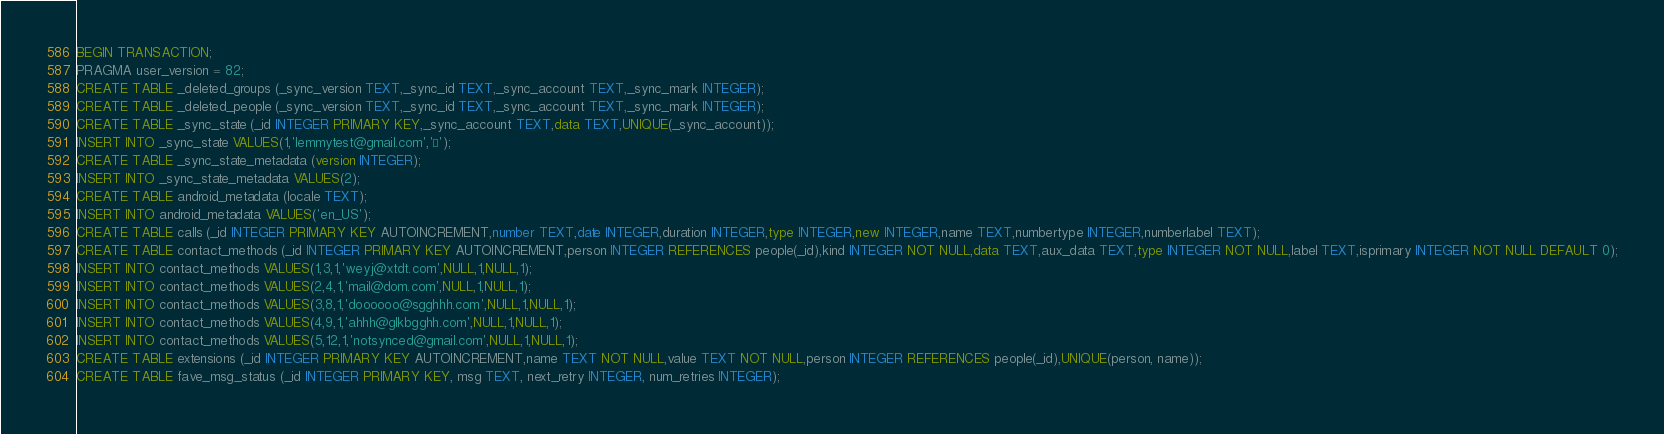Convert code to text. <code><loc_0><loc_0><loc_500><loc_500><_SQL_>BEGIN TRANSACTION;
PRAGMA user_version = 82; 
CREATE TABLE _deleted_groups (_sync_version TEXT,_sync_id TEXT,_sync_account TEXT,_sync_mark INTEGER);
CREATE TABLE _deleted_people (_sync_version TEXT,_sync_id TEXT,_sync_account TEXT,_sync_mark INTEGER);
CREATE TABLE _sync_state (_id INTEGER PRIMARY KEY,_sync_account TEXT,data TEXT,UNIQUE(_sync_account));
INSERT INTO _sync_state VALUES(1,'lemmytest@gmail.com','');
CREATE TABLE _sync_state_metadata (version INTEGER);
INSERT INTO _sync_state_metadata VALUES(2);
CREATE TABLE android_metadata (locale TEXT);
INSERT INTO android_metadata VALUES('en_US');
CREATE TABLE calls (_id INTEGER PRIMARY KEY AUTOINCREMENT,number TEXT,date INTEGER,duration INTEGER,type INTEGER,new INTEGER,name TEXT,numbertype INTEGER,numberlabel TEXT);
CREATE TABLE contact_methods (_id INTEGER PRIMARY KEY AUTOINCREMENT,person INTEGER REFERENCES people(_id),kind INTEGER NOT NULL,data TEXT,aux_data TEXT,type INTEGER NOT NULL,label TEXT,isprimary INTEGER NOT NULL DEFAULT 0);
INSERT INTO contact_methods VALUES(1,3,1,'weyj@xtdt.com',NULL,1,NULL,1);
INSERT INTO contact_methods VALUES(2,4,1,'mail@dom.com',NULL,1,NULL,1);
INSERT INTO contact_methods VALUES(3,8,1,'doooooo@sgghhh.com',NULL,1,NULL,1);
INSERT INTO contact_methods VALUES(4,9,1,'ahhh@glkbgghh.com',NULL,1,NULL,1);
INSERT INTO contact_methods VALUES(5,12,1,'notsynced@gmail.com',NULL,1,NULL,1);
CREATE TABLE extensions (_id INTEGER PRIMARY KEY AUTOINCREMENT,name TEXT NOT NULL,value TEXT NOT NULL,person INTEGER REFERENCES people(_id),UNIQUE(person, name));
CREATE TABLE fave_msg_status (_id INTEGER PRIMARY KEY, msg TEXT, next_retry INTEGER, num_retries INTEGER);</code> 